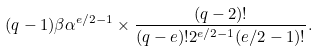<formula> <loc_0><loc_0><loc_500><loc_500>( q - 1 ) \beta \alpha ^ { e / 2 - 1 } \times \frac { ( q - 2 ) ! } { ( q - e ) ! 2 ^ { e / 2 - 1 } ( e / 2 - 1 ) ! } .</formula> 